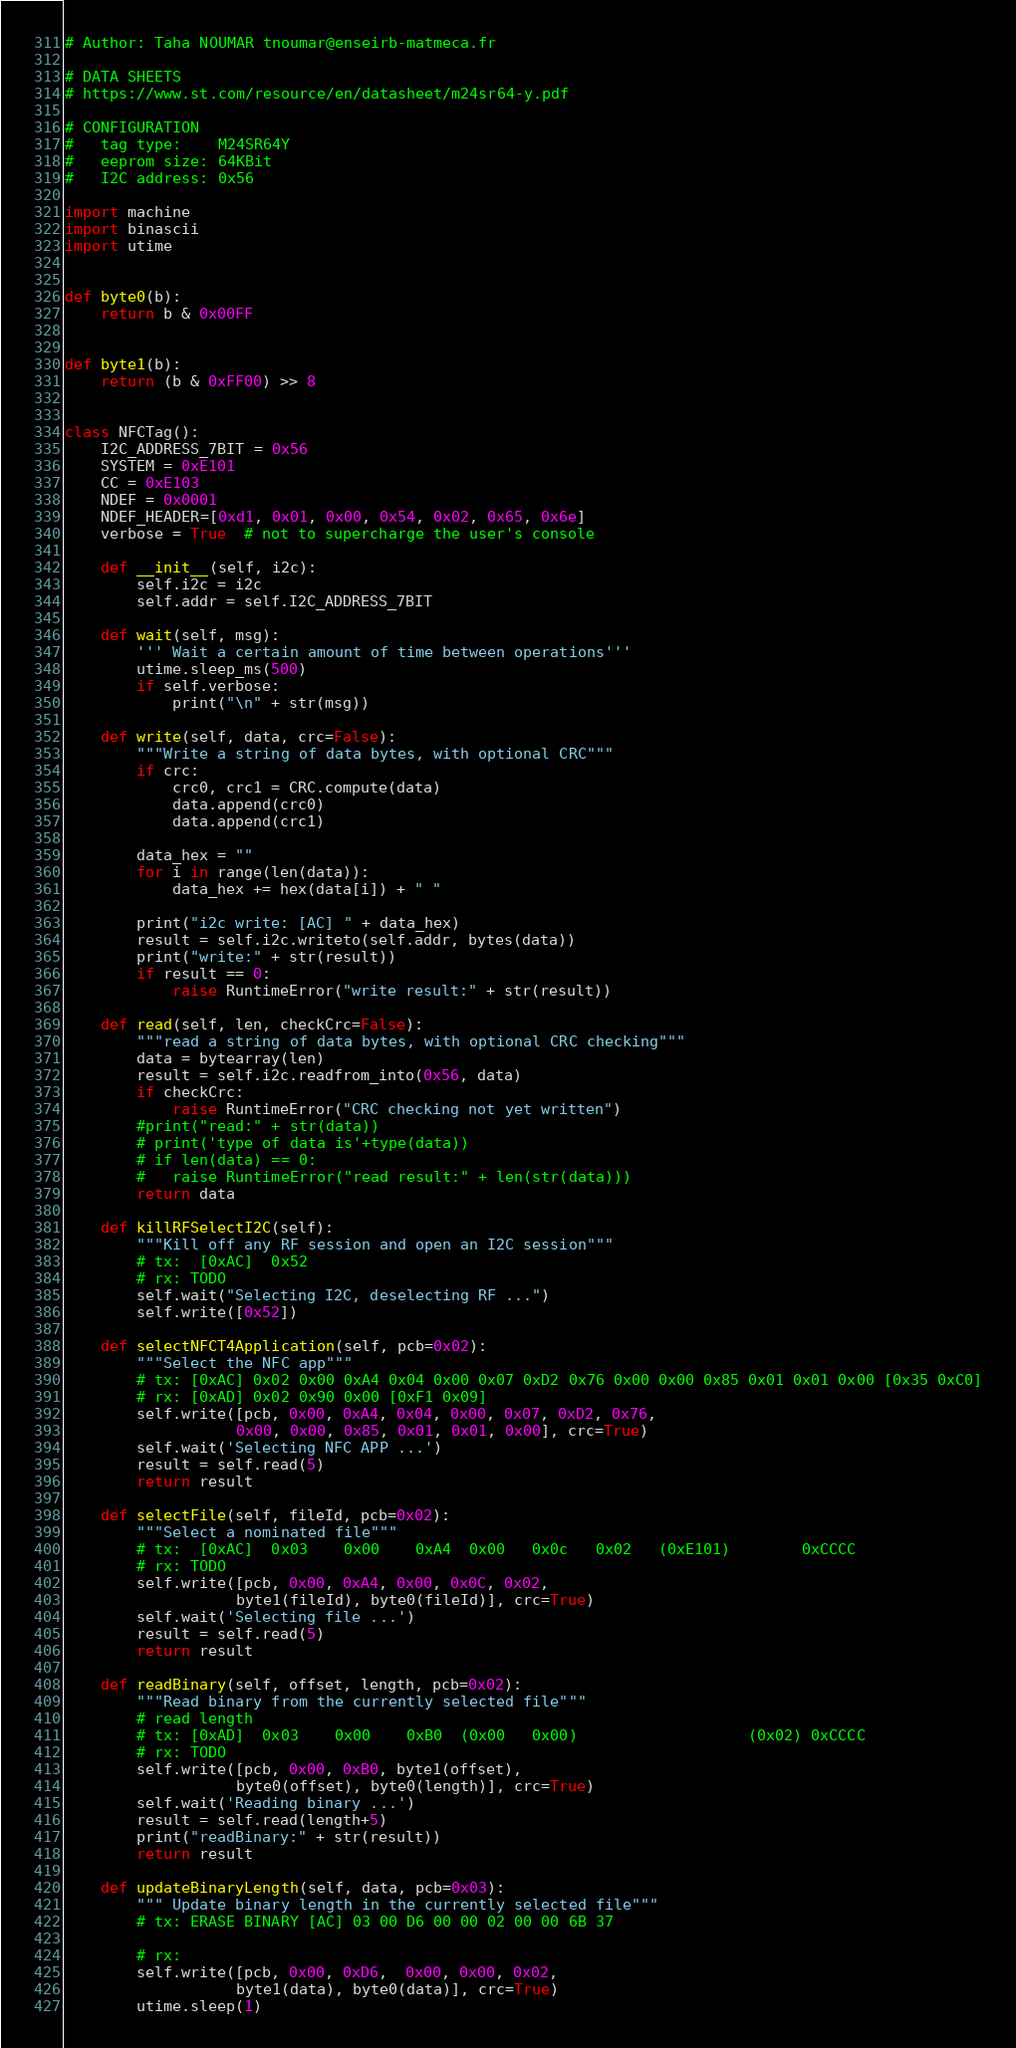<code> <loc_0><loc_0><loc_500><loc_500><_Python_># Author: Taha NOUMAR tnoumar@enseirb-matmeca.fr

# DATA SHEETS
# https://www.st.com/resource/en/datasheet/m24sr64-y.pdf

# CONFIGURATION
#   tag type:    M24SR64Y
#   eeprom size: 64KBit
#   I2C address: 0x56

import machine
import binascii
import utime


def byte0(b):
    return b & 0x00FF


def byte1(b):
    return (b & 0xFF00) >> 8


class NFCTag():
    I2C_ADDRESS_7BIT = 0x56
    SYSTEM = 0xE101
    CC = 0xE103
    NDEF = 0x0001
    NDEF_HEADER=[0xd1, 0x01, 0x00, 0x54, 0x02, 0x65, 0x6e]
    verbose = True  # not to supercharge the user's console

    def __init__(self, i2c):
        self.i2c = i2c
        self.addr = self.I2C_ADDRESS_7BIT

    def wait(self, msg):
        ''' Wait a certain amount of time between operations'''
        utime.sleep_ms(500)
        if self.verbose:
            print("\n" + str(msg))

    def write(self, data, crc=False):
        """Write a string of data bytes, with optional CRC"""
        if crc:
            crc0, crc1 = CRC.compute(data)
            data.append(crc0)
            data.append(crc1)

        data_hex = ""
        for i in range(len(data)):
            data_hex += hex(data[i]) + " "

        print("i2c write: [AC] " + data_hex)
        result = self.i2c.writeto(self.addr, bytes(data))
        print("write:" + str(result))
        if result == 0:
            raise RuntimeError("write result:" + str(result))

    def read(self, len, checkCrc=False):
        """read a string of data bytes, with optional CRC checking"""
        data = bytearray(len)
        result = self.i2c.readfrom_into(0x56, data)
        if checkCrc:
            raise RuntimeError("CRC checking not yet written")
        #print("read:" + str(data))
        # print('type of data is'+type(data))
        # if len(data) == 0:
        #   raise RuntimeError("read result:" + len(str(data)))
        return data

    def killRFSelectI2C(self):
        """Kill off any RF session and open an I2C session"""
        # tx:  [0xAC]  0x52
        # rx: TODO
        self.wait("Selecting I2C, deselecting RF ...")
        self.write([0x52])

    def selectNFCT4Application(self, pcb=0x02):
        """Select the NFC app"""
        # tx: [0xAC] 0x02 0x00 0xA4 0x04 0x00 0x07 0xD2 0x76 0x00 0x00 0x85 0x01 0x01 0x00 [0x35 0xC0]
        # rx: [0xAD] 0x02 0x90 0x00 [0xF1 0x09]
        self.write([pcb, 0x00, 0xA4, 0x04, 0x00, 0x07, 0xD2, 0x76,
                   0x00, 0x00, 0x85, 0x01, 0x01, 0x00], crc=True)
        self.wait('Selecting NFC APP ...')
        result = self.read(5)
        return result

    def selectFile(self, fileId, pcb=0x02):
        """Select a nominated file"""
        # tx:  [0xAC]  0x03    0x00    0xA4  0x00   0x0c   0x02   (0xE101)        0xCCCC
        # rx: TODO
        self.write([pcb, 0x00, 0xA4, 0x00, 0x0C, 0x02,
                   byte1(fileId), byte0(fileId)], crc=True)
        self.wait('Selecting file ...')
        result = self.read(5)
        return result

    def readBinary(self, offset, length, pcb=0x02):
        """Read binary from the currently selected file"""
        # read length
        # tx: [0xAD]  0x03    0x00    0xB0  (0x00   0x00)                   (0x02) 0xCCCC
        # rx: TODO
        self.write([pcb, 0x00, 0xB0, byte1(offset),
                   byte0(offset), byte0(length)], crc=True)
        self.wait('Reading binary ...')
        result = self.read(length+5)
        print("readBinary:" + str(result))
        return result

    def updateBinaryLength(self, data, pcb=0x03):
        """ Update binary length in the currently selected file"""
        # tx: ERASE BINARY [AC] 03 00 D6 00 00 02 00 00 6B 37

        # rx:
        self.write([pcb, 0x00, 0xD6,  0x00, 0x00, 0x02,
                   byte1(data), byte0(data)], crc=True)
        utime.sleep(1)</code> 